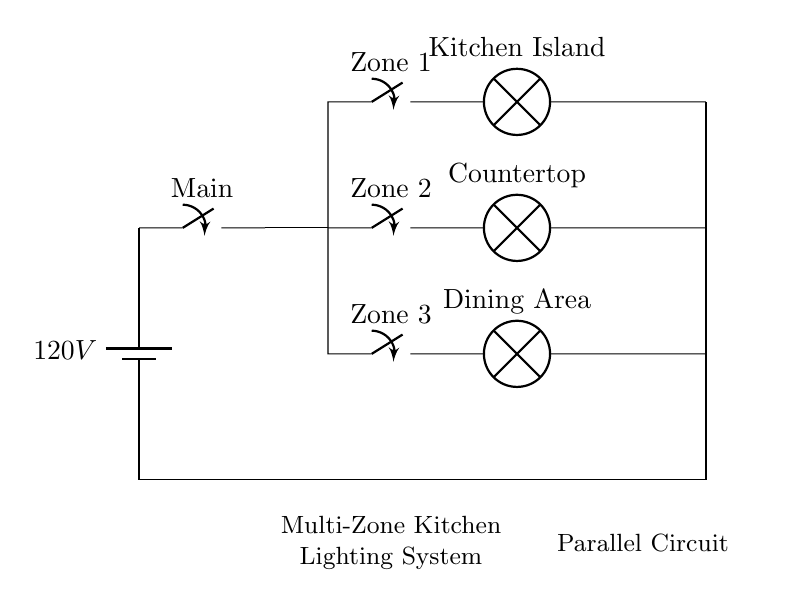What is the voltage of this circuit? The voltage is 120V, which is indicated by the battery symbol at the top of the circuit diagram.
Answer: 120V How many zones are in the lighting system? There are three zones labeled as Zone 1, Zone 2, and Zone 3 in the circuit.
Answer: Three What components are connected in parallel? The lamps for Kitchen Island, Countertop, and Dining Area are connected in parallel, as they have separate branches from the main switch.
Answer: Kitchen Island, Countertop, Dining Area What is the function of the main switch? The main switch controls the entire circuit, allowing or blocking current flow to all connected zones simultaneously.
Answer: Control Which zone has separate lighting control? Each zone (Zone 1, Zone 2, Zone 3) has its own switch, allowing for separate control of lighting in those areas.
Answer: All zones What happens if one lamp fails in this circuit? If one lamp fails, the other lamps in their respective zones will continue to function since they are on separate branches of the parallel circuit.
Answer: Continue to function 